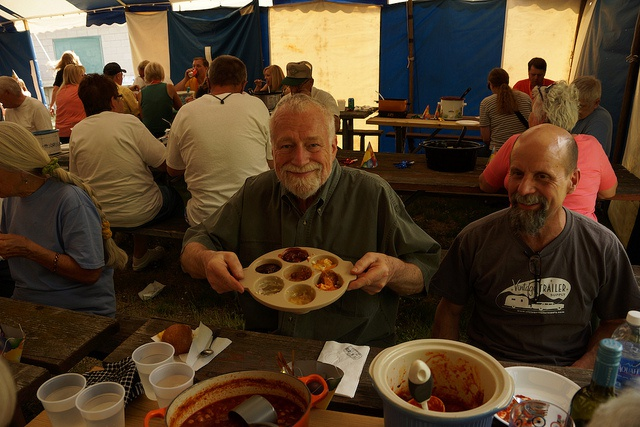Describe the objects in this image and their specific colors. I can see dining table in beige, black, maroon, and tan tones, people in beige, black, maroon, and brown tones, people in beige, black, maroon, and brown tones, people in beige, black, maroon, and olive tones, and people in beige, olive, black, and maroon tones in this image. 